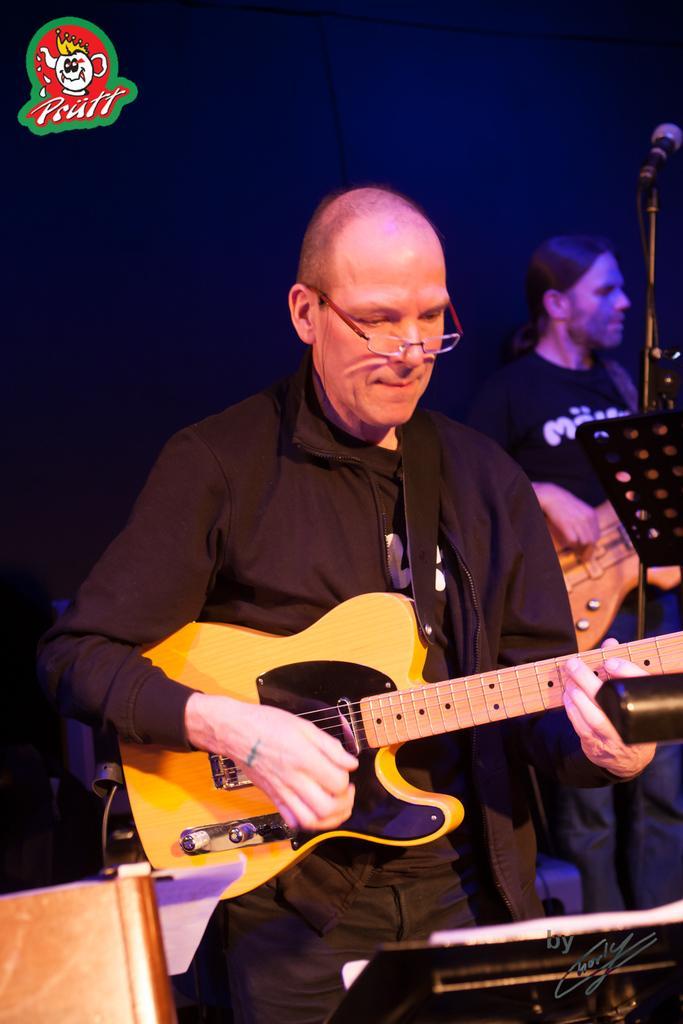Please provide a concise description of this image. In this picture there is a bald man who is playing a guitar. In the back I can see another man who is also playing a guitar. In front of them I can see the stand and mic. In the bottom left corner there is a chair. In the background I can see the blur image. In the top left corner there is a watermark. 